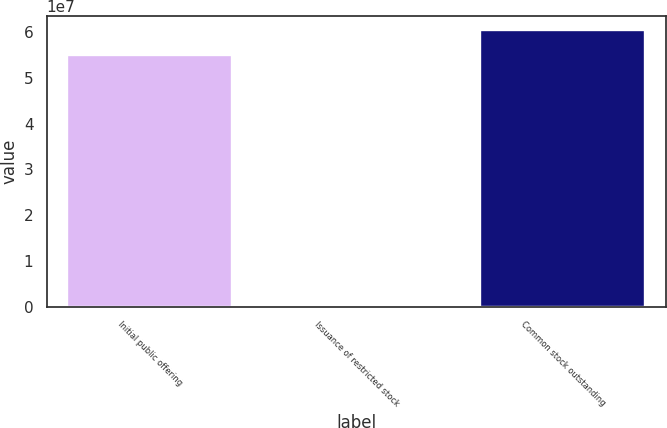Convert chart to OTSL. <chart><loc_0><loc_0><loc_500><loc_500><bar_chart><fcel>Initial public offering<fcel>Issuance of restricted stock<fcel>Common stock outstanding<nl><fcel>5.5e+07<fcel>27724<fcel>6.05e+07<nl></chart> 